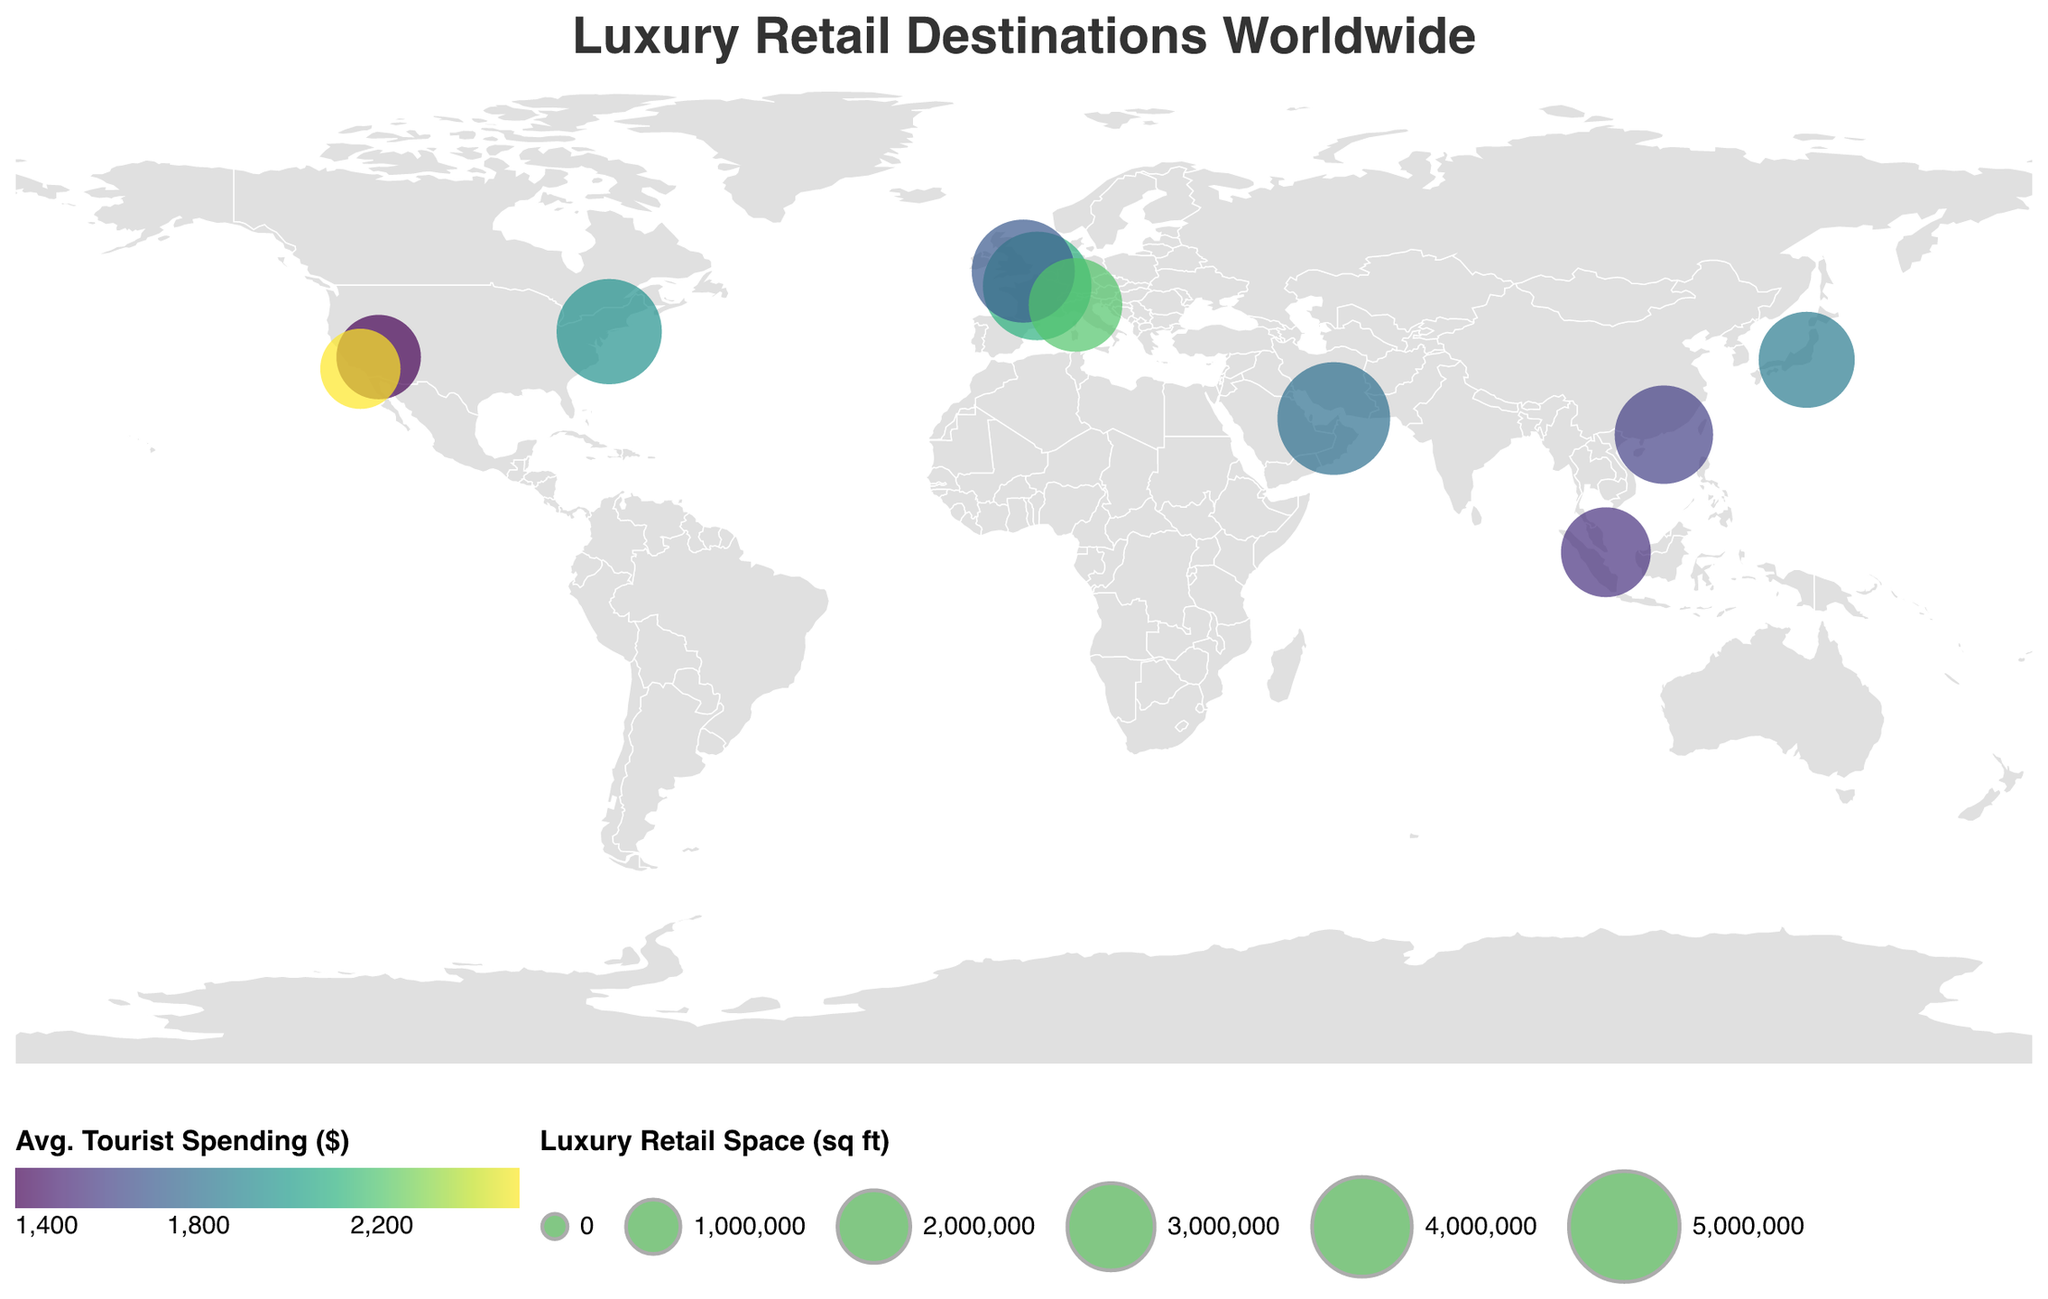What is the title of the figure? The title appears at the top of the figure and summarises the central theme, which is "Luxury Retail Destinations Worldwide"
Answer: Luxury Retail Destinations Worldwide How many tourist hotspots are displayed in the figure? Count the number of data points (dots) representing tourist hotspots on the map. Each dot corresponds to a location listed in the data provided.
Answer: 10 Which location has the highest average tourist spending? Compare the color intensities corresponding to different locations and find the one with the highest intensity, indicating the highest average tourist spending. The tooltip information reveals that Beverly Hills has the highest value.
Answer: Beverly Hills Which tourist hotspot has the largest luxury retail space? Look at the size of the circles on the map. The largest circle corresponds to Dubai, indicating it has the largest luxury retail space among the locations shown.
Answer: Dubai How many locations have an annual tourist count of over 20 million? Check the tooltip data for each location to see which ones have more than 20 million annual tourists. Both London (21.7 million) and Las Vegas (42.5 million) meet this criterion.
Answer: 2 Which location has the smallest luxury retail space, and what is its value? Identify the smallest circle on the map. The smallest circle corresponds to Beverly Hills, indicating it has the smallest luxury retail space. Use the tooltip to confirm.
Answer: Beverly Hills, 2,500,000 sq ft Compare the average tourist spending between Paris and New York City. Which location has higher spending? Use the tooltip to find the average tourist spending for both Paris ($2,100) and New York City ($1,950). Paris has higher average tourist spending.
Answer: Paris Is there a location with more annual tourists than Sydney but less luxury retail space than Hong Kong? Compare the annual tourist counts and luxury retail space between locations to match the criteria. Las Vegas has more annual tourists (42.5 million) than Sydney's highest count and has less luxury retail space (2,800,000 sq ft) than Hong Kong (3,900,000 sq ft).
Answer: Las Vegas What's the total luxury retail space across all locations? Sum up the luxury retail space values for all the locations provided in the data. Integrate the spaces: 5200000 (Dubai) + 4800000 (Paris) + 4500000 (New York City) + 4300000 (London) + 3900000 (Hong Kong) + 3700000 (Tokyo) + 3500000 (Milan) + 3200000 (Singapore) + 2800000 (Las Vegas) + 2500000 (Beverly Hills) = 38,200,000 sq ft
Answer: 38,200,000 sq ft 